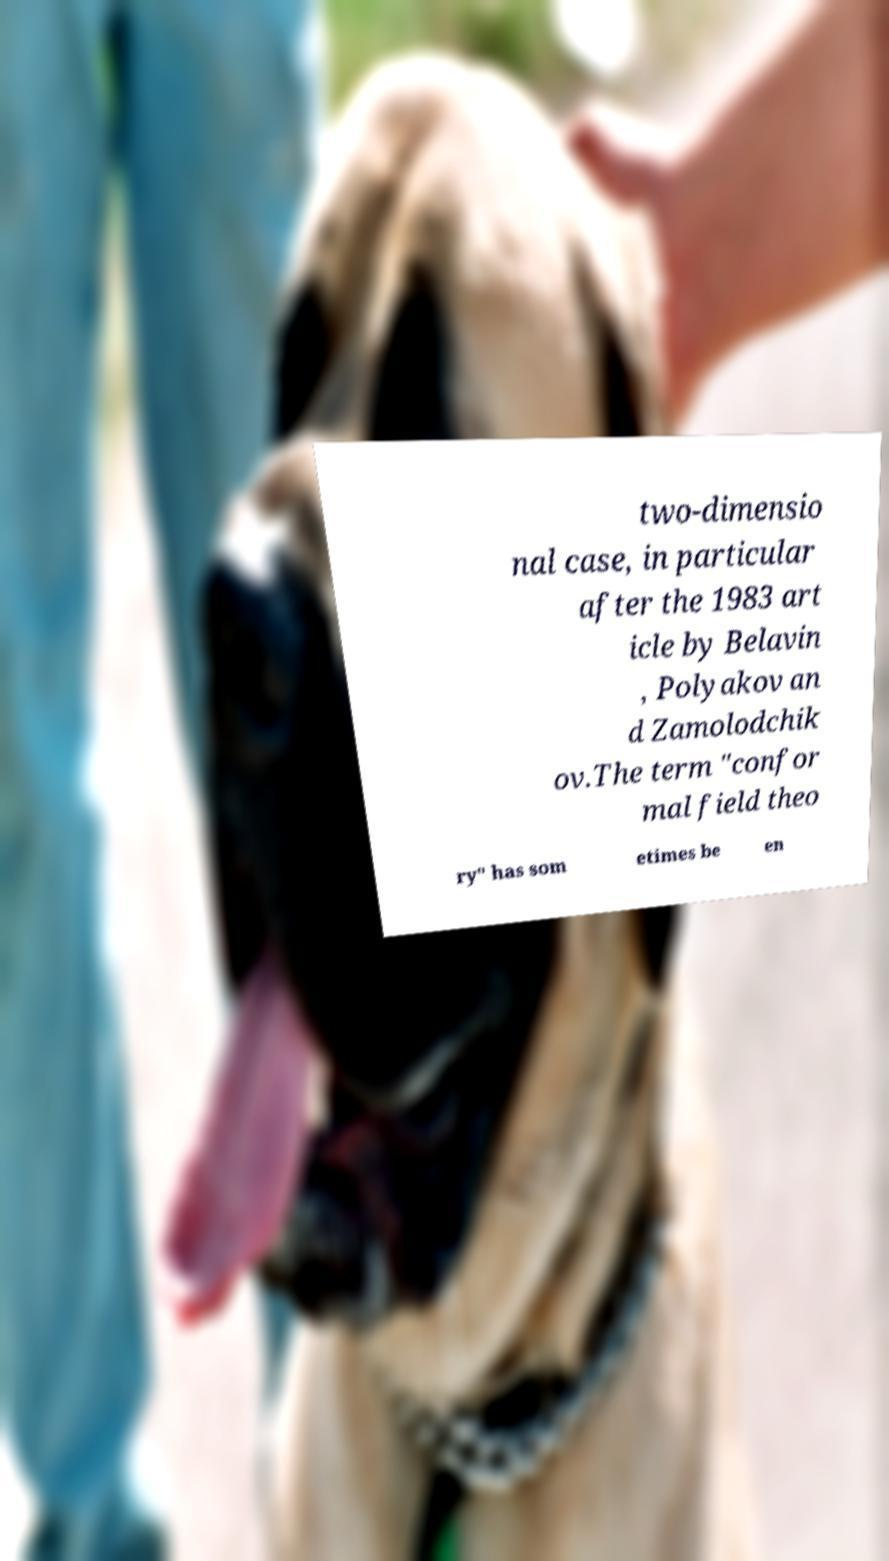There's text embedded in this image that I need extracted. Can you transcribe it verbatim? two-dimensio nal case, in particular after the 1983 art icle by Belavin , Polyakov an d Zamolodchik ov.The term "confor mal field theo ry" has som etimes be en 